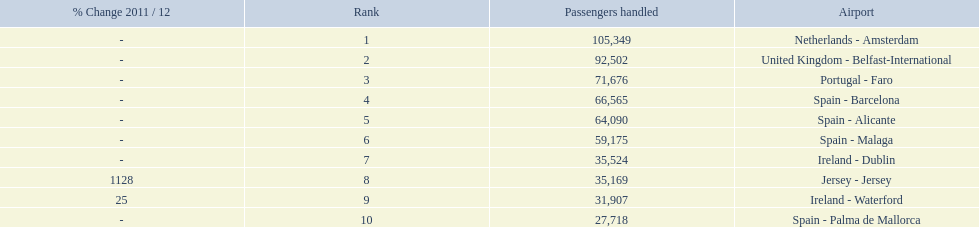How many passengers were handled in an airport in spain? 217,548. 